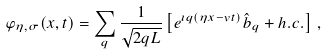Convert formula to latex. <formula><loc_0><loc_0><loc_500><loc_500>\varphi _ { \eta , \sigma } ( x , t ) = \sum _ { q } \frac { 1 } { \sqrt { 2 q L } } \left [ e ^ { \imath q ( \eta x - v t ) } \hat { b } _ { q } + h . c . \right ] \, ,</formula> 